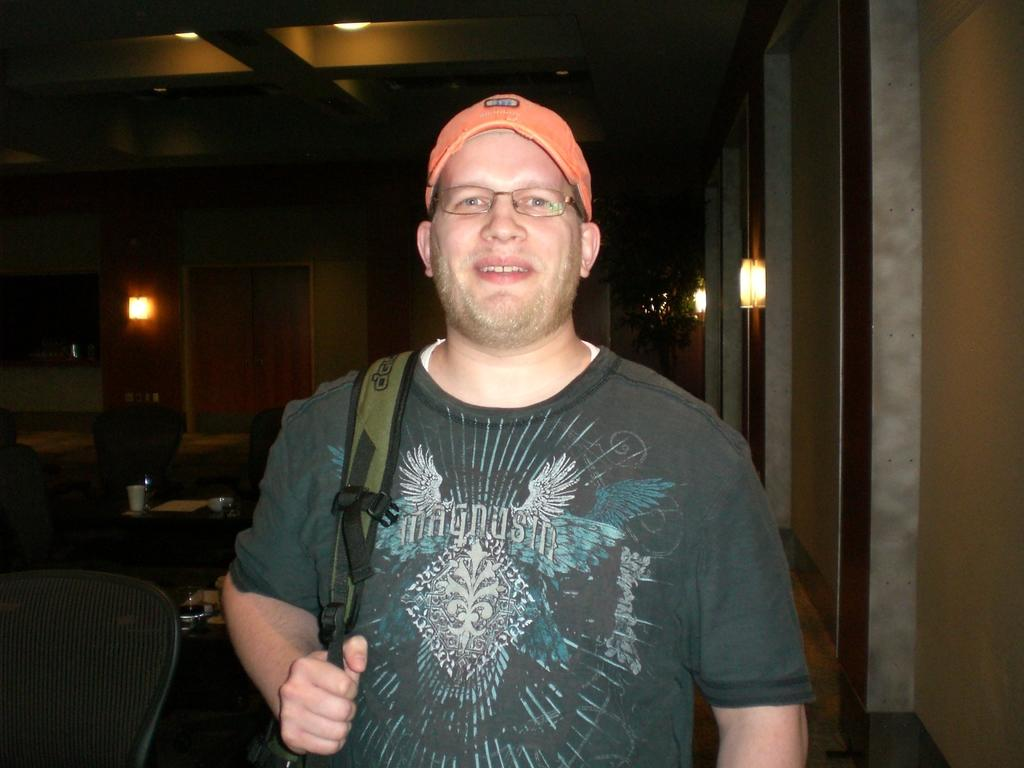What is the person in the image doing? The person is standing in the image. What is the person holding in the image? The person is holding a bag. How does the person appear to be feeling in the image? The person has a smile on their face. What type of furniture can be seen behind the person? There are chairs and tables behind the person. What type of poison is the person consuming in the image? There is no indication in the image that the person is consuming any poison; they are holding a bag and have a smile on their face. 